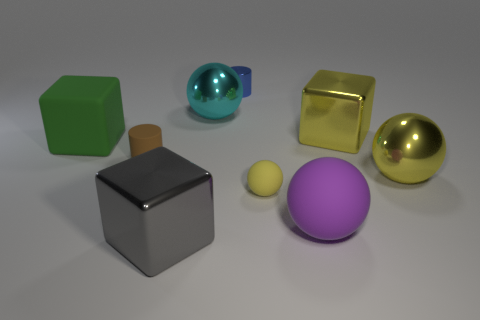There is a small thing that is behind the tiny yellow matte sphere and right of the large gray object; what is its shape?
Give a very brief answer. Cylinder. Do the large block to the right of the big gray metal block and the large green block have the same material?
Your response must be concise. No. What color is the matte cube that is the same size as the purple object?
Your response must be concise. Green. Is there a thing of the same color as the tiny sphere?
Your answer should be compact. Yes. What size is the cyan sphere that is the same material as the blue object?
Provide a succinct answer. Large. What size is the other ball that is the same color as the tiny ball?
Offer a terse response. Large. How many other things are the same size as the blue thing?
Keep it short and to the point. 2. There is a small cylinder that is in front of the green rubber thing; what is its material?
Provide a succinct answer. Rubber. The big yellow thing in front of the small thing on the left side of the tiny cylinder to the right of the gray metal object is what shape?
Provide a short and direct response. Sphere. Is the yellow shiny sphere the same size as the blue metal cylinder?
Make the answer very short. No. 